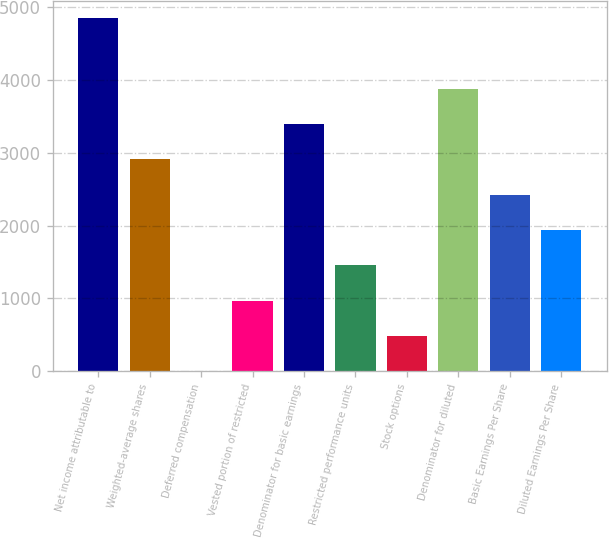<chart> <loc_0><loc_0><loc_500><loc_500><bar_chart><fcel>Net income attributable to<fcel>Weighted-average shares<fcel>Deferred compensation<fcel>Vested portion of restricted<fcel>Denominator for basic earnings<fcel>Restricted performance units<fcel>Stock options<fcel>Denominator for diluted<fcel>Basic Earnings Per Share<fcel>Diluted Earnings Per Share<nl><fcel>4844<fcel>2906.8<fcel>1<fcel>969.6<fcel>3391.1<fcel>1453.9<fcel>485.3<fcel>3875.4<fcel>2422.5<fcel>1938.2<nl></chart> 